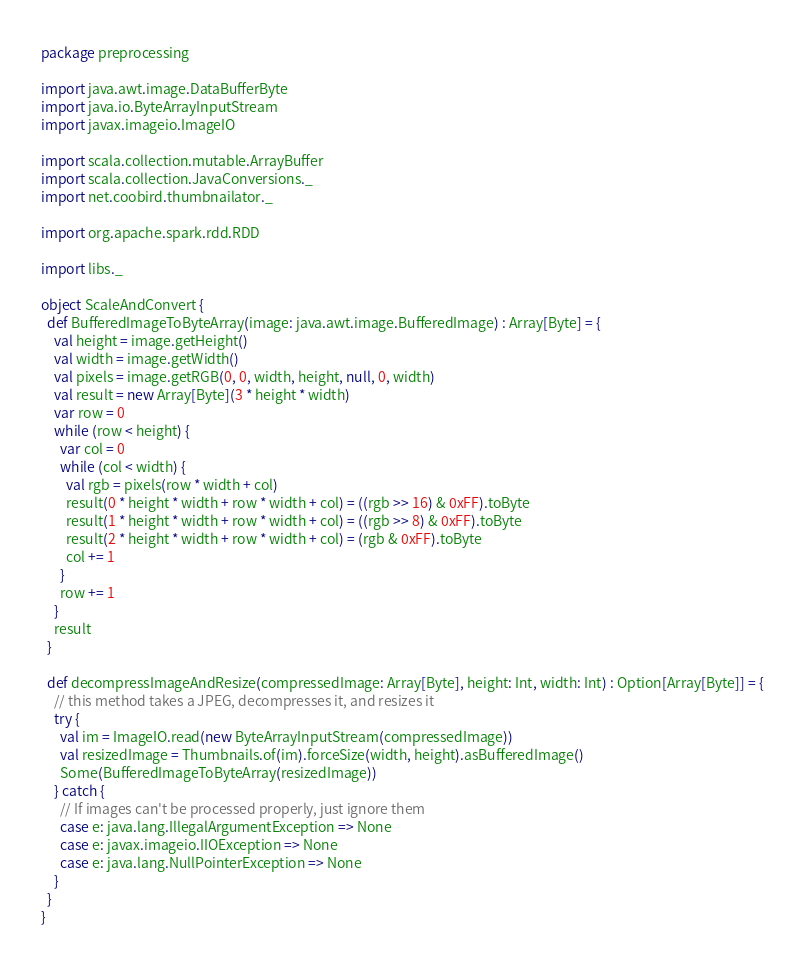Convert code to text. <code><loc_0><loc_0><loc_500><loc_500><_Scala_>package preprocessing

import java.awt.image.DataBufferByte
import java.io.ByteArrayInputStream
import javax.imageio.ImageIO

import scala.collection.mutable.ArrayBuffer
import scala.collection.JavaConversions._
import net.coobird.thumbnailator._

import org.apache.spark.rdd.RDD

import libs._

object ScaleAndConvert {
  def BufferedImageToByteArray(image: java.awt.image.BufferedImage) : Array[Byte] = {
    val height = image.getHeight()
    val width = image.getWidth()
    val pixels = image.getRGB(0, 0, width, height, null, 0, width)
    val result = new Array[Byte](3 * height * width)
    var row = 0
    while (row < height) {
      var col = 0
      while (col < width) {
        val rgb = pixels(row * width + col)
        result(0 * height * width + row * width + col) = ((rgb >> 16) & 0xFF).toByte
        result(1 * height * width + row * width + col) = ((rgb >> 8) & 0xFF).toByte
        result(2 * height * width + row * width + col) = (rgb & 0xFF).toByte
        col += 1
      }
      row += 1
    }
    result
  }

  def decompressImageAndResize(compressedImage: Array[Byte], height: Int, width: Int) : Option[Array[Byte]] = {
    // this method takes a JPEG, decompresses it, and resizes it
    try {
      val im = ImageIO.read(new ByteArrayInputStream(compressedImage))
      val resizedImage = Thumbnails.of(im).forceSize(width, height).asBufferedImage()
      Some(BufferedImageToByteArray(resizedImage))
    } catch {
      // If images can't be processed properly, just ignore them
      case e: java.lang.IllegalArgumentException => None
      case e: javax.imageio.IIOException => None
      case e: java.lang.NullPointerException => None
    }
  }
}
</code> 